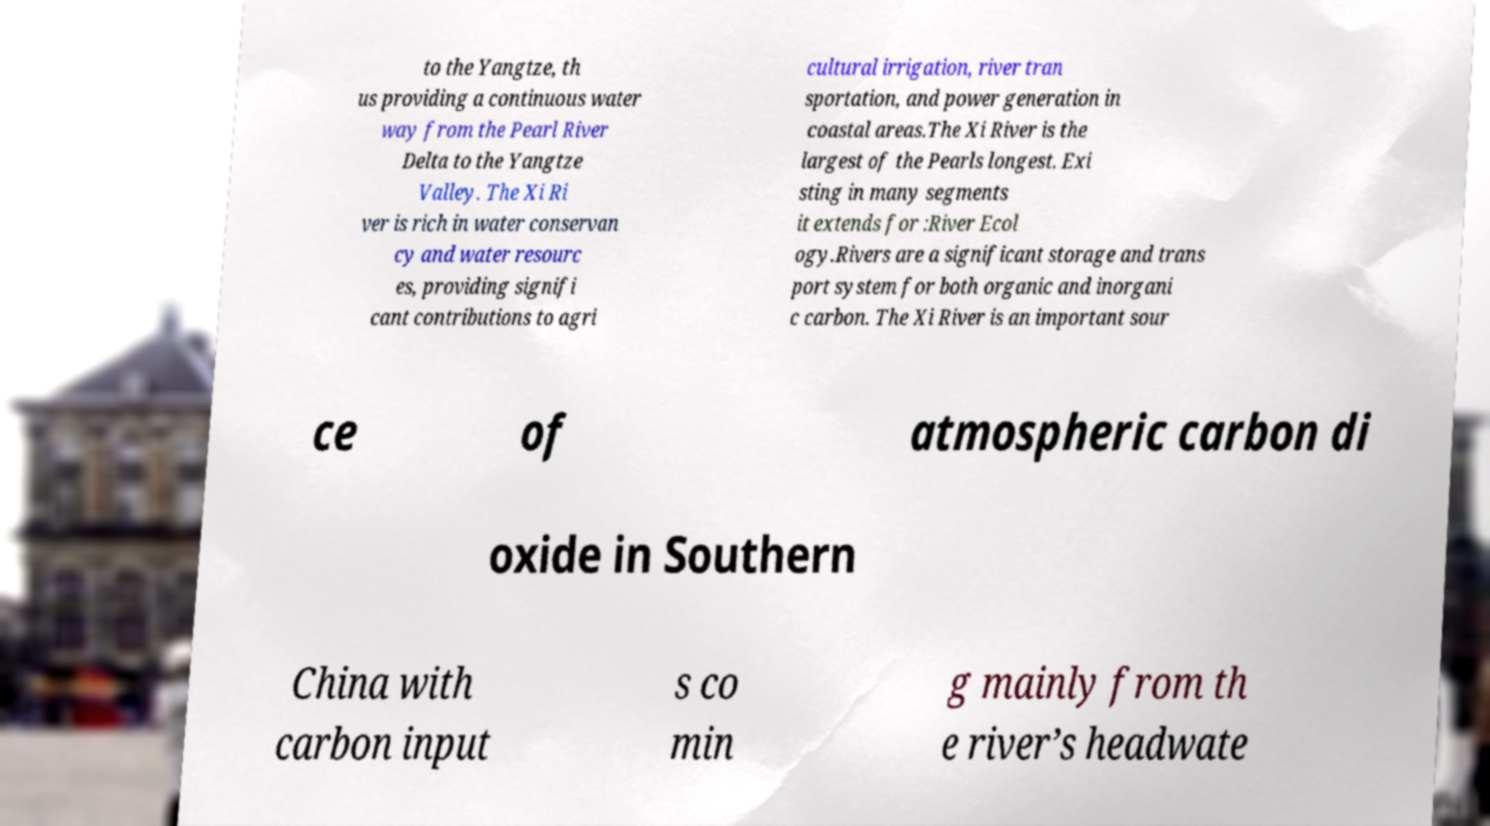There's text embedded in this image that I need extracted. Can you transcribe it verbatim? to the Yangtze, th us providing a continuous water way from the Pearl River Delta to the Yangtze Valley. The Xi Ri ver is rich in water conservan cy and water resourc es, providing signifi cant contributions to agri cultural irrigation, river tran sportation, and power generation in coastal areas.The Xi River is the largest of the Pearls longest. Exi sting in many segments it extends for :River Ecol ogy.Rivers are a significant storage and trans port system for both organic and inorgani c carbon. The Xi River is an important sour ce of atmospheric carbon di oxide in Southern China with carbon input s co min g mainly from th e river’s headwate 